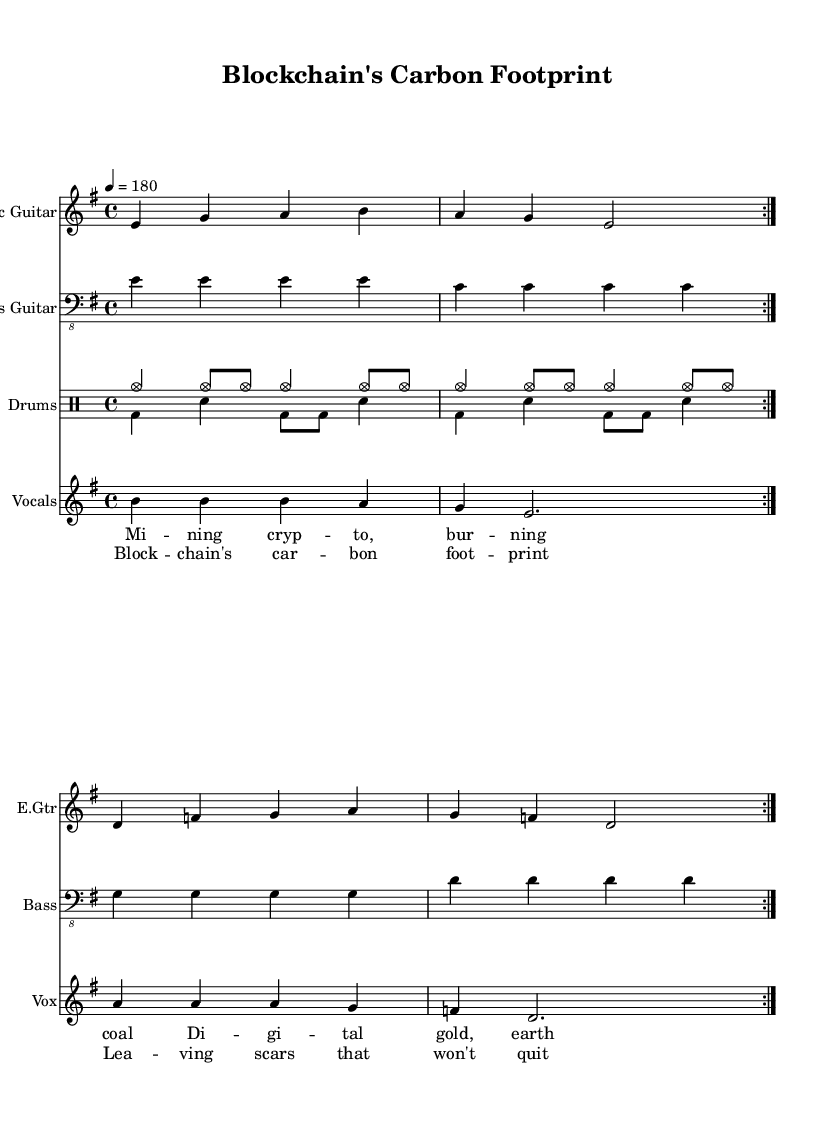What is the key signature of this music? The key signature shows E minor, which has one sharp (F#) indicated at the beginning of the staff. This is the first thing to identify when looking at the sheet music.
Answer: E minor What is the time signature of this music? The time signature is indicated at the beginning of the piece and shows 4/4, which means there are four beats in each measure and the quarter note gets one beat. This can be verified by looking directly following the clef.
Answer: 4/4 What is the tempo marking of this music? The tempo marking is located at the start of the score, where it is indicated as quarter note equals 180 beats per minute, meaning the music is to be played quickly and energetically.
Answer: 180 How many times is the electric guitar part repeated? The electric guitar part has the instruction to repeat it two times, as shown by the repeated volta markings at the beginning of the section. This indicates that the section should be played twice.
Answer: 2 What is the main lyrical theme of this song? The lyrics express a concern regarding the environmental impact of blockchain and cryptocurrency mining, as suggested by phrases in the lyrics related to carbon footprints and environmental tolls. This can be deduced from the phrases "burning coal" and "earth pays the toll."
Answer: Environmental impact What instruments are included in this music arrangement? The score outlines multiple instruments: it includes electric guitar, bass guitar, drums, and vocals as distinctly labeled at the beginning of each staff. Each instrument is clearly named, showing what is included in the arrangement.
Answer: Electric guitar, bass guitar, drums, vocals What type of music genre does this piece represent? The overall style of the piece, which features aggressive guitar riffs, fast tempos, and themes of rebellion and social commentary, indicates that it clearly belongs to the punk genre. This can be inferred from the energetic presentation and lyrical content.
Answer: Punk 